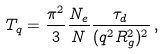Convert formula to latex. <formula><loc_0><loc_0><loc_500><loc_500>T _ { q } = \frac { \pi ^ { 2 } } { 3 } \frac { N _ { e } } { N } \frac { \tau _ { d } } { ( q ^ { 2 } R _ { g } ^ { 2 } ) ^ { 2 } } \, ,</formula> 